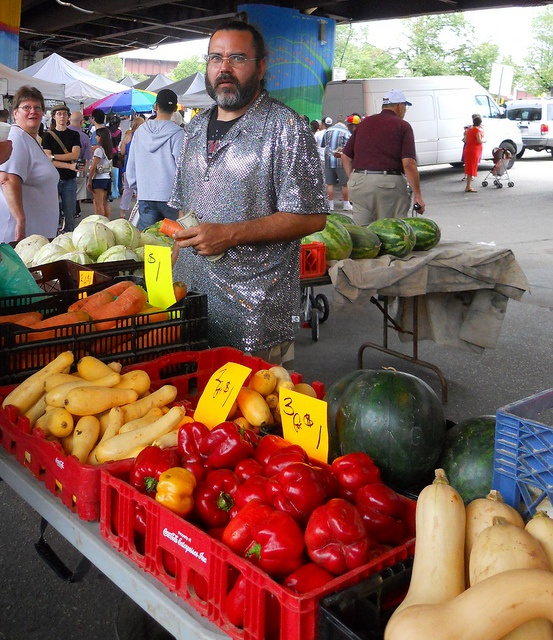Describe the objects in this image and their specific colors. I can see people in maroon, gray, black, and darkgray tones, truck in maroon, white, gray, and black tones, people in maroon, gray, black, and darkgray tones, people in maroon, gray, and darkgray tones, and people in maroon, darkgray, lavender, and black tones in this image. 